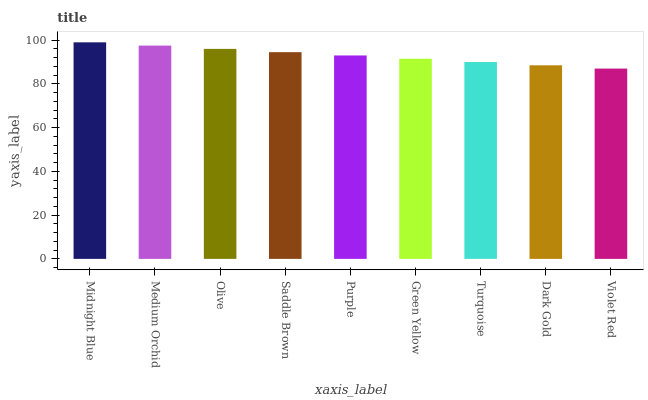Is Violet Red the minimum?
Answer yes or no. Yes. Is Midnight Blue the maximum?
Answer yes or no. Yes. Is Medium Orchid the minimum?
Answer yes or no. No. Is Medium Orchid the maximum?
Answer yes or no. No. Is Midnight Blue greater than Medium Orchid?
Answer yes or no. Yes. Is Medium Orchid less than Midnight Blue?
Answer yes or no. Yes. Is Medium Orchid greater than Midnight Blue?
Answer yes or no. No. Is Midnight Blue less than Medium Orchid?
Answer yes or no. No. Is Purple the high median?
Answer yes or no. Yes. Is Purple the low median?
Answer yes or no. Yes. Is Green Yellow the high median?
Answer yes or no. No. Is Medium Orchid the low median?
Answer yes or no. No. 